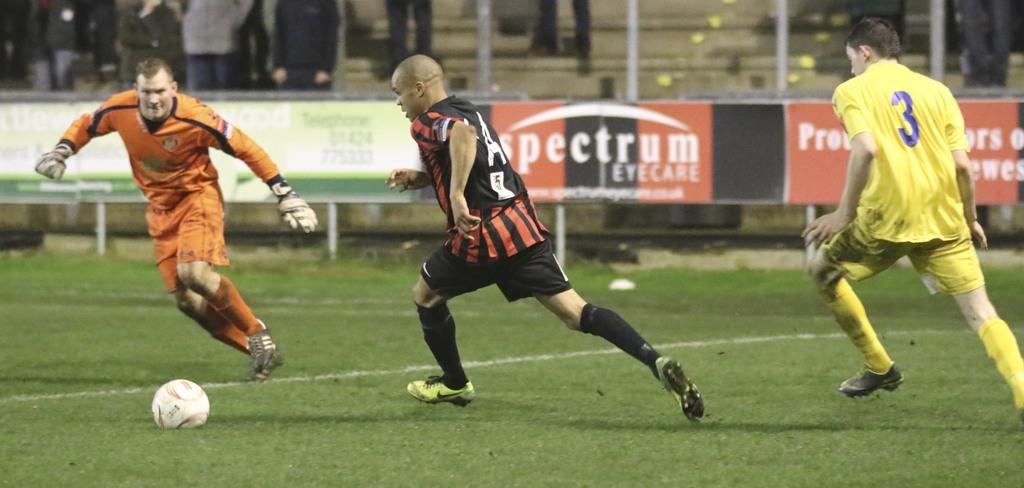What does the board in the back say?
Offer a very short reply. Spectrum. Is there a player labled with a number?
Provide a short and direct response. Yes. 